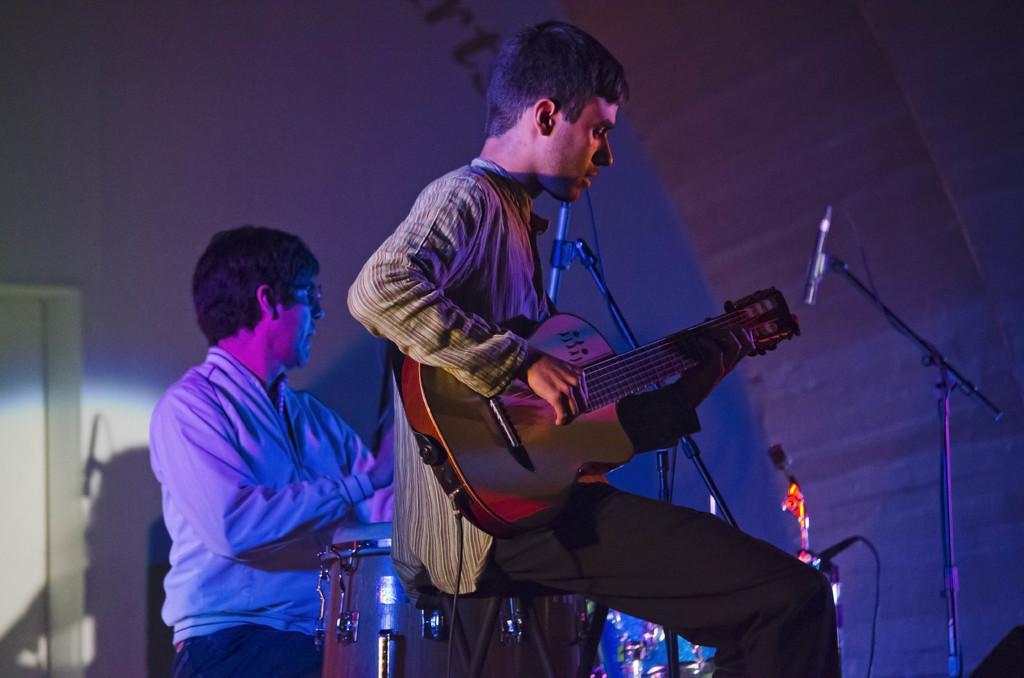How would you summarize this image in a sentence or two? In this picture there is a man playing guitar. There is a person, drum and a mic. 